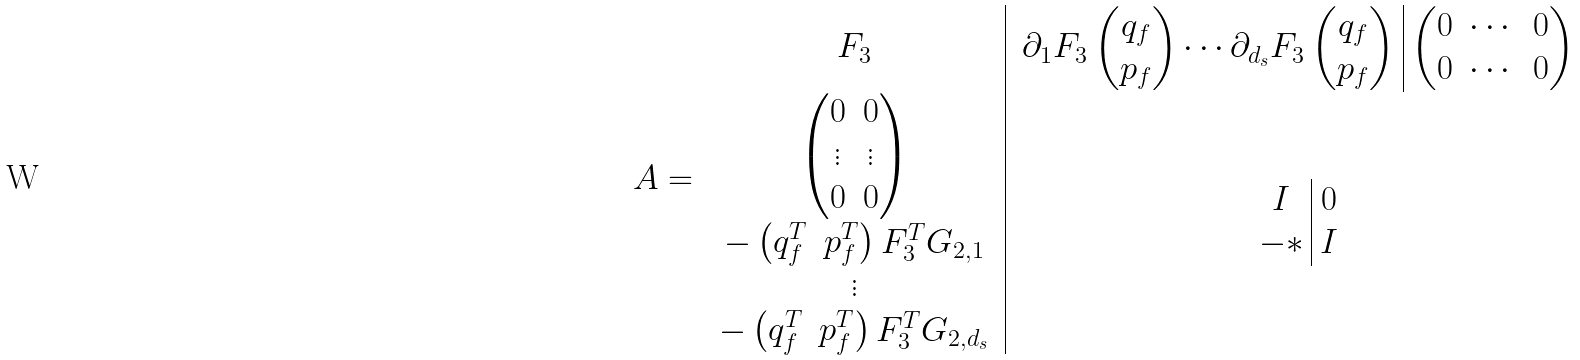<formula> <loc_0><loc_0><loc_500><loc_500>A = \begin{array} { c | c } F _ { 3 } & \begin{array} { c | c } \partial _ { 1 } F _ { 3 } \begin{pmatrix} q _ { f } \\ p _ { f } \end{pmatrix} \cdots \partial _ { d _ { s } } F _ { 3 } \begin{pmatrix} q _ { f } \\ p _ { f } \end{pmatrix} & \begin{pmatrix} 0 & \cdots & 0 \\ 0 & \cdots & 0 \end{pmatrix} \end{array} \\ \begin{array} { c } \begin{pmatrix} 0 & 0 \\ \vdots & \vdots \\ 0 & 0 \end{pmatrix} \\ - \begin{pmatrix} q _ { f } ^ { T } & p _ { f } ^ { T } \end{pmatrix} F _ { 3 } ^ { T } G _ { 2 , 1 } \\ \vdots \\ - \begin{pmatrix} q _ { f } ^ { T } & p _ { f } ^ { T } \end{pmatrix} F _ { 3 } ^ { T } G _ { 2 , d _ { s } } \end{array} & \begin{array} { c | c } I & 0 \\ - * & I \end{array} \end{array}</formula> 